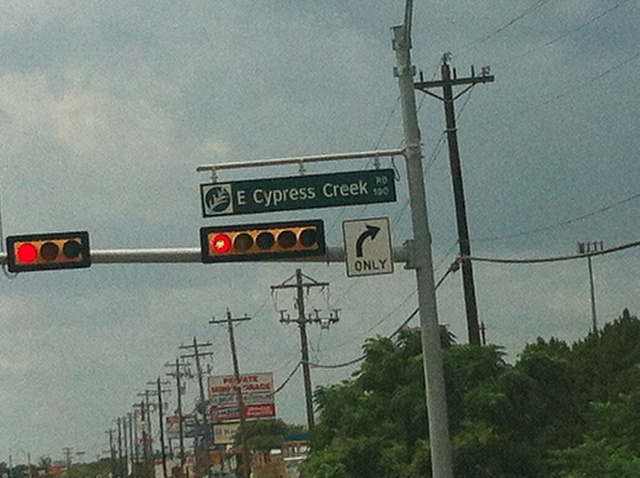Describe the objects in this image and their specific colors. I can see traffic light in darkgray, black, maroon, and red tones and traffic light in darkgray, black, red, and maroon tones in this image. 